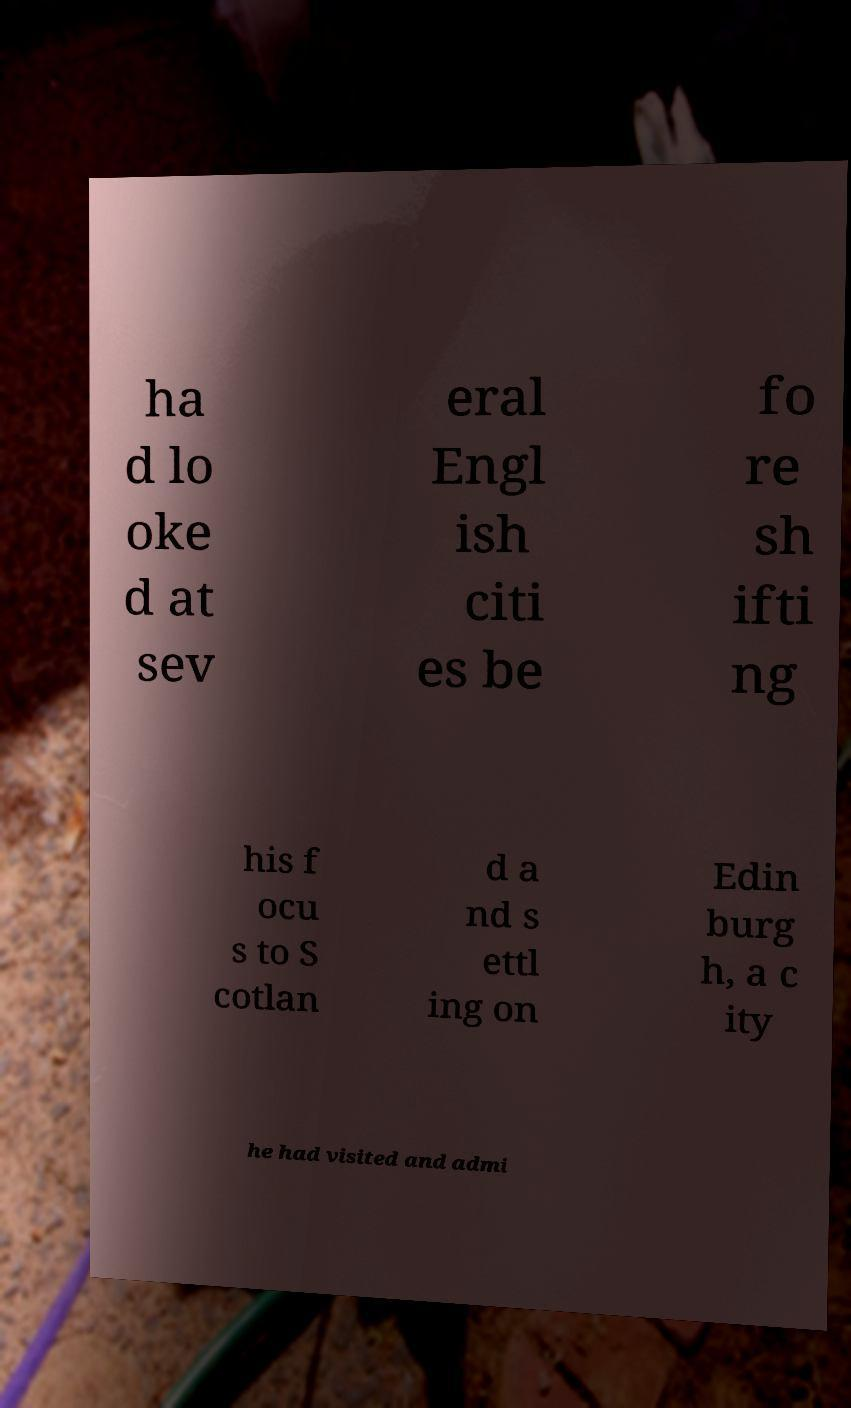What messages or text are displayed in this image? I need them in a readable, typed format. ha d lo oke d at sev eral Engl ish citi es be fo re sh ifti ng his f ocu s to S cotlan d a nd s ettl ing on Edin burg h, a c ity he had visited and admi 